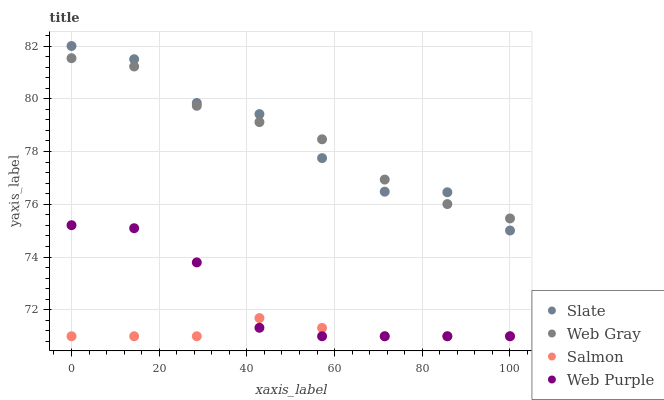Does Salmon have the minimum area under the curve?
Answer yes or no. Yes. Does Web Gray have the maximum area under the curve?
Answer yes or no. Yes. Does Web Gray have the minimum area under the curve?
Answer yes or no. No. Does Salmon have the maximum area under the curve?
Answer yes or no. No. Is Salmon the smoothest?
Answer yes or no. Yes. Is Slate the roughest?
Answer yes or no. Yes. Is Web Gray the smoothest?
Answer yes or no. No. Is Web Gray the roughest?
Answer yes or no. No. Does Salmon have the lowest value?
Answer yes or no. Yes. Does Web Gray have the lowest value?
Answer yes or no. No. Does Slate have the highest value?
Answer yes or no. Yes. Does Web Gray have the highest value?
Answer yes or no. No. Is Web Purple less than Web Gray?
Answer yes or no. Yes. Is Slate greater than Salmon?
Answer yes or no. Yes. Does Web Purple intersect Salmon?
Answer yes or no. Yes. Is Web Purple less than Salmon?
Answer yes or no. No. Is Web Purple greater than Salmon?
Answer yes or no. No. Does Web Purple intersect Web Gray?
Answer yes or no. No. 